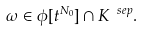Convert formula to latex. <formula><loc_0><loc_0><loc_500><loc_500>\omega \in \phi [ t ^ { N _ { 0 } } ] \cap K ^ { \ s e p } .</formula> 